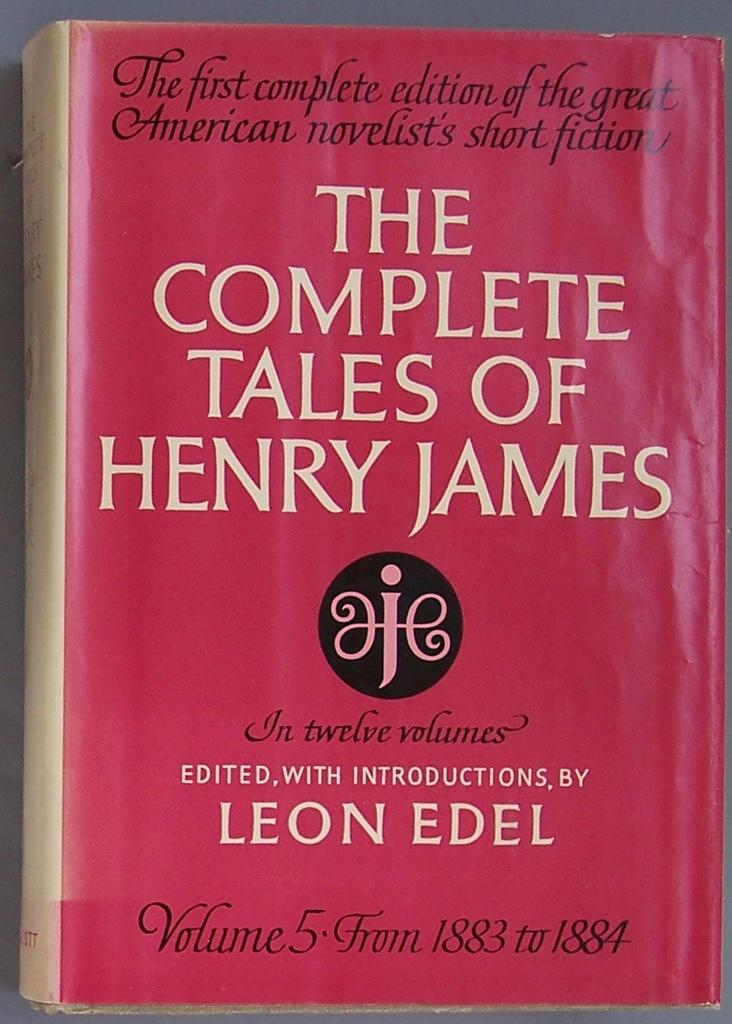Provide a one-sentence caption for the provided image. book with red cover, the complete tales of henry james. 